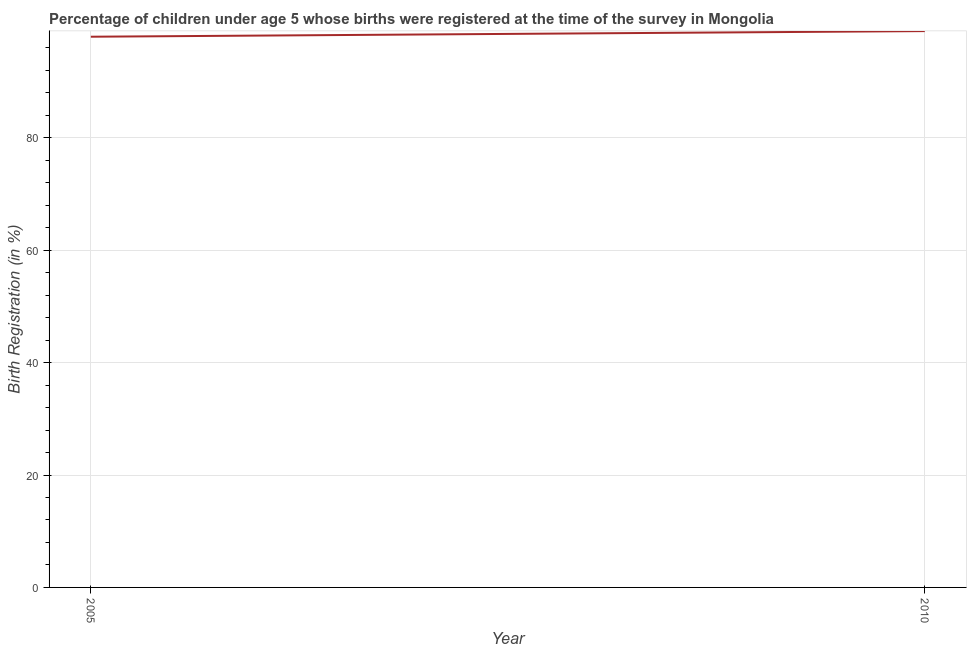What is the birth registration in 2005?
Offer a very short reply. 98. Across all years, what is the maximum birth registration?
Make the answer very short. 99. Across all years, what is the minimum birth registration?
Your answer should be very brief. 98. In which year was the birth registration minimum?
Ensure brevity in your answer.  2005. What is the sum of the birth registration?
Provide a short and direct response. 197. What is the difference between the birth registration in 2005 and 2010?
Your answer should be very brief. -1. What is the average birth registration per year?
Your answer should be compact. 98.5. What is the median birth registration?
Offer a very short reply. 98.5. In how many years, is the birth registration greater than 56 %?
Provide a short and direct response. 2. What is the ratio of the birth registration in 2005 to that in 2010?
Give a very brief answer. 0.99. Is the birth registration in 2005 less than that in 2010?
Your answer should be compact. Yes. In how many years, is the birth registration greater than the average birth registration taken over all years?
Your answer should be compact. 1. Does the birth registration monotonically increase over the years?
Give a very brief answer. Yes. How many lines are there?
Make the answer very short. 1. How many years are there in the graph?
Make the answer very short. 2. What is the title of the graph?
Keep it short and to the point. Percentage of children under age 5 whose births were registered at the time of the survey in Mongolia. What is the label or title of the Y-axis?
Provide a short and direct response. Birth Registration (in %). What is the Birth Registration (in %) in 2005?
Provide a short and direct response. 98. What is the Birth Registration (in %) of 2010?
Offer a very short reply. 99. 